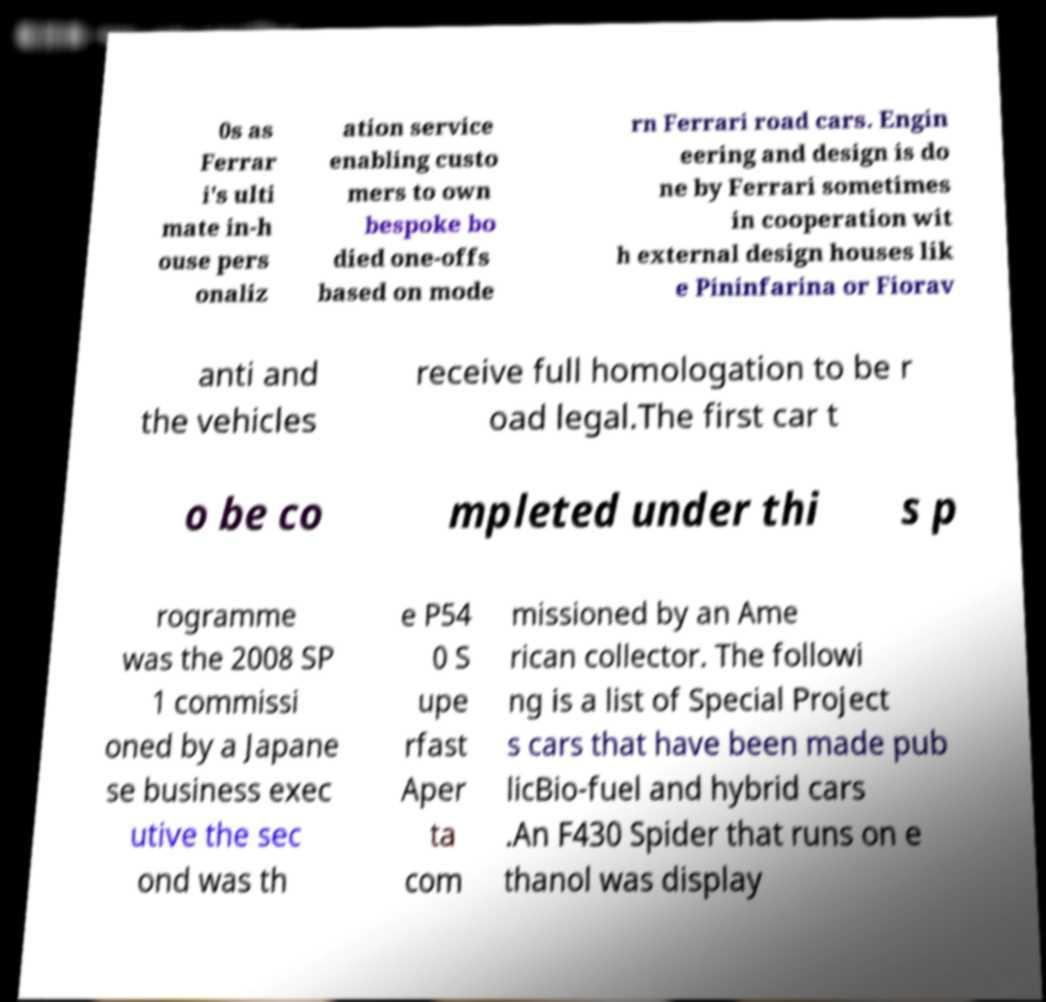Please read and relay the text visible in this image. What does it say? 0s as Ferrar i's ulti mate in-h ouse pers onaliz ation service enabling custo mers to own bespoke bo died one-offs based on mode rn Ferrari road cars. Engin eering and design is do ne by Ferrari sometimes in cooperation wit h external design houses lik e Pininfarina or Fiorav anti and the vehicles receive full homologation to be r oad legal.The first car t o be co mpleted under thi s p rogramme was the 2008 SP 1 commissi oned by a Japane se business exec utive the sec ond was th e P54 0 S upe rfast Aper ta com missioned by an Ame rican collector. The followi ng is a list of Special Project s cars that have been made pub licBio-fuel and hybrid cars .An F430 Spider that runs on e thanol was display 